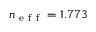Convert formula to latex. <formula><loc_0><loc_0><loc_500><loc_500>n _ { e f f } = 1 . 7 7 3</formula> 